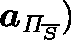Convert formula to latex. <formula><loc_0><loc_0><loc_500><loc_500>a _ { \Pi _ { \overline { S } } } )</formula> 